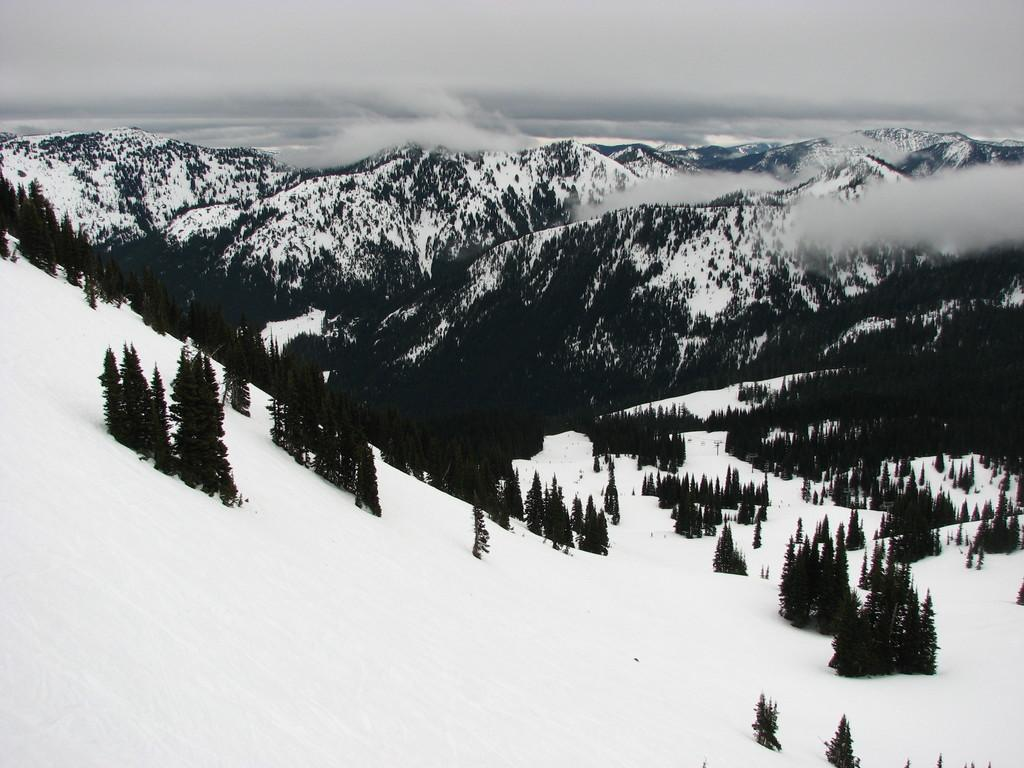What is the primary weather condition in the image? There is snow in the image. What type of natural features can be seen in the background of the image? There are trees, mountains, and fog visible in the background of the image. What part of the sky is visible in the image? The sky is visible in the background of the image. How many drains are visible in the image? There are no drains present in the image. What type of birds can be seen flying in the image? There are no birds visible in the image. 